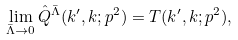Convert formula to latex. <formula><loc_0><loc_0><loc_500><loc_500>\lim _ { \bar { \Lambda } \rightarrow 0 } \hat { Q } ^ { \bar { \Lambda } } ( k ^ { \prime } , k ; p ^ { 2 } ) = T ( k ^ { \prime } , k ; p ^ { 2 } ) ,</formula> 